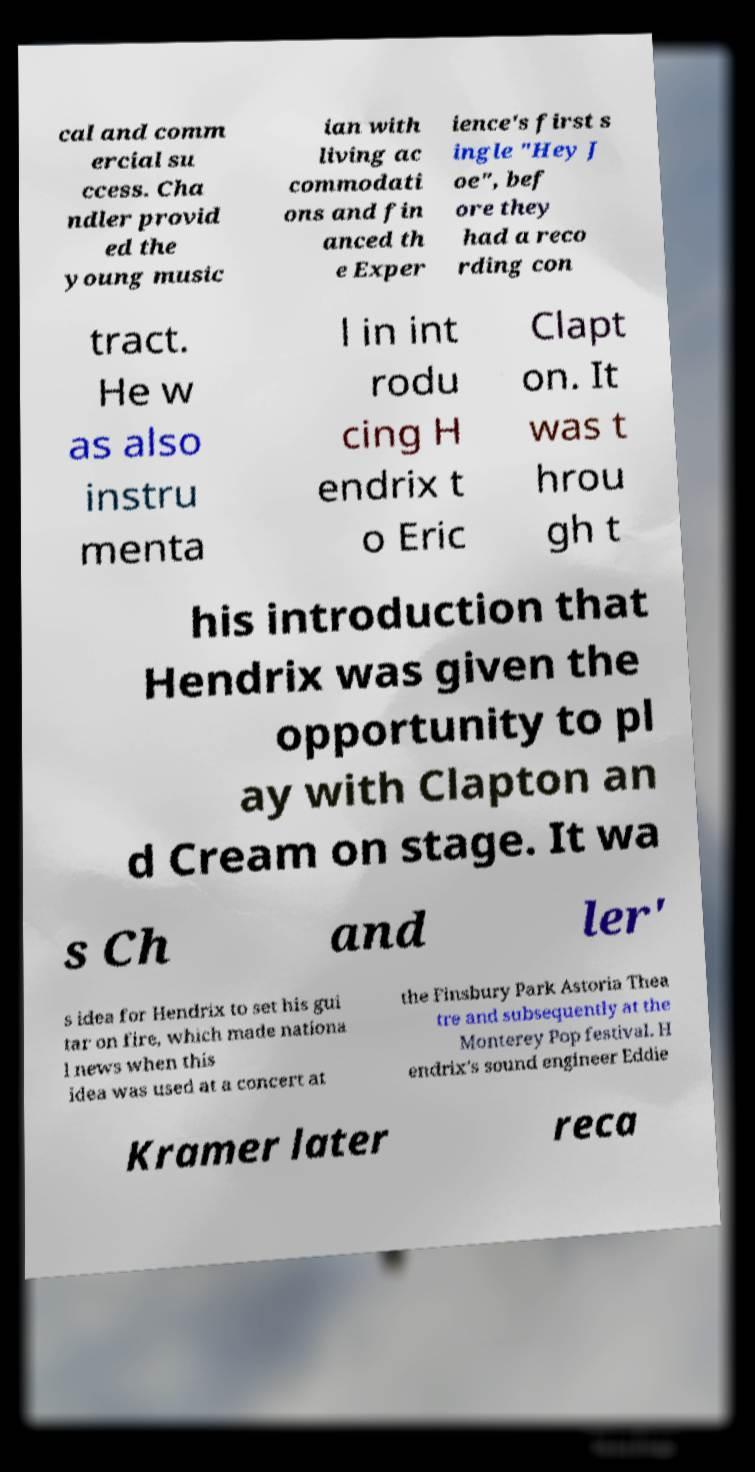Can you accurately transcribe the text from the provided image for me? cal and comm ercial su ccess. Cha ndler provid ed the young music ian with living ac commodati ons and fin anced th e Exper ience's first s ingle "Hey J oe", bef ore they had a reco rding con tract. He w as also instru menta l in int rodu cing H endrix t o Eric Clapt on. It was t hrou gh t his introduction that Hendrix was given the opportunity to pl ay with Clapton an d Cream on stage. It wa s Ch and ler' s idea for Hendrix to set his gui tar on fire, which made nationa l news when this idea was used at a concert at the Finsbury Park Astoria Thea tre and subsequently at the Monterey Pop festival. H endrix's sound engineer Eddie Kramer later reca 